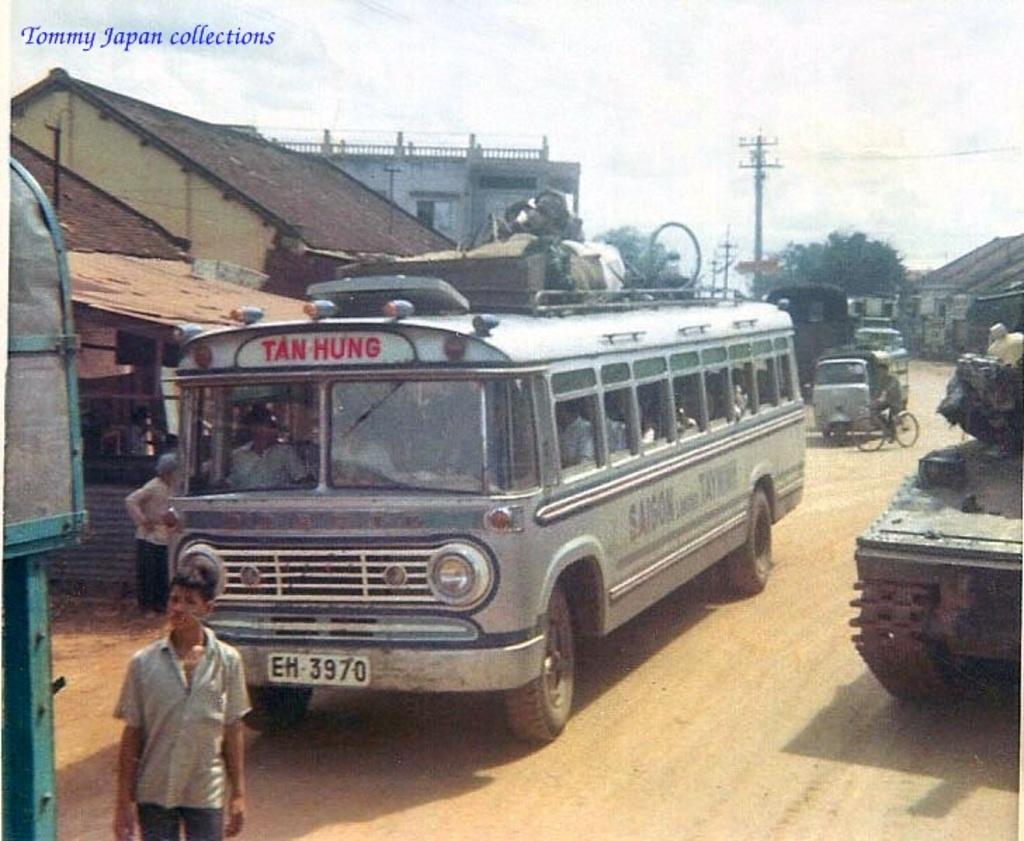<image>
Share a concise interpretation of the image provided. Old and dusty truck which says Tan Hung on it. 